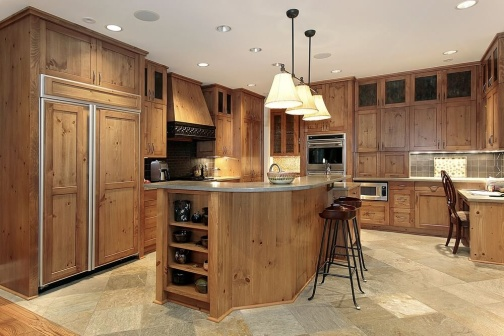What could be the benefits of having a central island with bar stools in the kitchen? The central island with bar stools encourages a communal cooking experience, making the kitchen a social hub where family or guests can gather. It allows the cook to interact freely with others while preparing meals, turning cooking into a more inclusive and enjoyable activity. Additionally, the island provides extra work surface and storage space, which can help in managing meal preparation more effectively. 